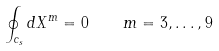<formula> <loc_0><loc_0><loc_500><loc_500>\oint _ { c _ { s } } d X ^ { m } = 0 \quad m = 3 , \dots , 9</formula> 